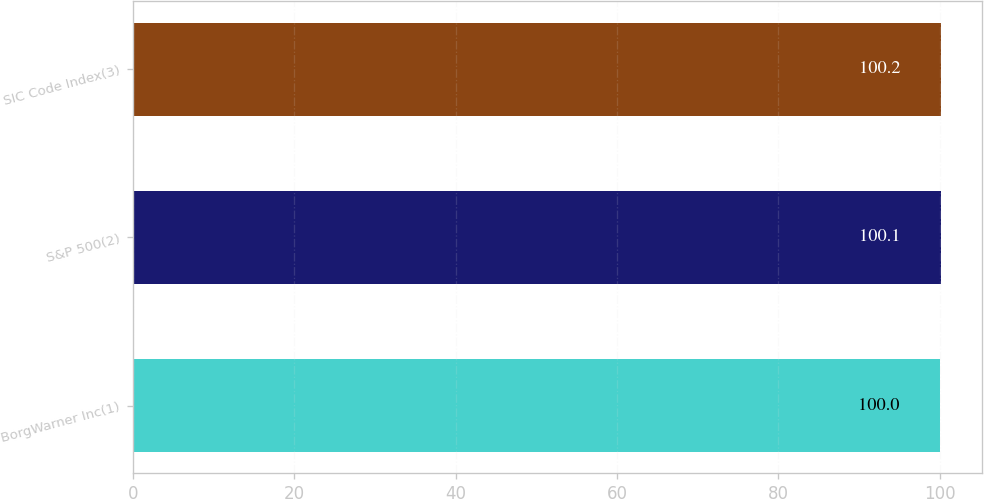<chart> <loc_0><loc_0><loc_500><loc_500><bar_chart><fcel>BorgWarner Inc(1)<fcel>S&P 500(2)<fcel>SIC Code Index(3)<nl><fcel>100<fcel>100.1<fcel>100.2<nl></chart> 